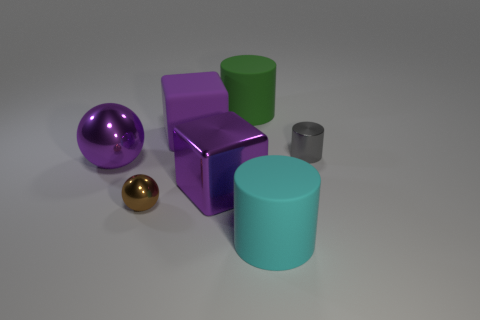What is the size of the purple metal cube?
Ensure brevity in your answer.  Large. Does the small cylinder have the same color as the large ball?
Give a very brief answer. No. How many objects are either green matte cylinders or big objects that are on the right side of the green cylinder?
Your response must be concise. 2. What number of large purple metallic blocks are right of the brown shiny object behind the rubber object that is in front of the small gray thing?
Offer a very short reply. 1. There is another large block that is the same color as the rubber cube; what is its material?
Your response must be concise. Metal. What number of tiny metallic balls are there?
Your response must be concise. 1. There is a object on the right side of the cyan matte thing; is its size the same as the cyan cylinder?
Provide a short and direct response. No. How many shiny objects are either large red things or large purple things?
Ensure brevity in your answer.  2. There is a big purple metal thing left of the brown shiny sphere; how many big purple shiny objects are in front of it?
Offer a terse response. 1. What shape is the large rubber thing that is in front of the large green matte cylinder and behind the small brown metallic thing?
Provide a succinct answer. Cube. 